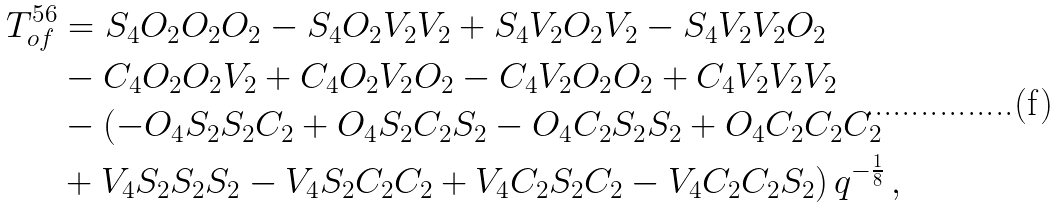Convert formula to latex. <formula><loc_0><loc_0><loc_500><loc_500>T ^ { 5 6 } _ { o f } & = S _ { 4 } O _ { 2 } O _ { 2 } O _ { 2 } - S _ { 4 } O _ { 2 } V _ { 2 } V _ { 2 } + S _ { 4 } V _ { 2 } O _ { 2 } V _ { 2 } - S _ { 4 } V _ { 2 } V _ { 2 } O _ { 2 } \\ & - C _ { 4 } O _ { 2 } O _ { 2 } V _ { 2 } + C _ { 4 } O _ { 2 } V _ { 2 } O _ { 2 } - C _ { 4 } V _ { 2 } O _ { 2 } O _ { 2 } + C _ { 4 } V _ { 2 } V _ { 2 } V _ { 2 } \\ & - ( - O _ { 4 } S _ { 2 } S _ { 2 } C _ { 2 } + O _ { 4 } S _ { 2 } C _ { 2 } S _ { 2 } - O _ { 4 } C _ { 2 } S _ { 2 } S _ { 2 } + O _ { 4 } C _ { 2 } C _ { 2 } C _ { 2 } \\ & + V _ { 4 } S _ { 2 } S _ { 2 } S _ { 2 } - V _ { 4 } S _ { 2 } C _ { 2 } C _ { 2 } + V _ { 4 } C _ { 2 } S _ { 2 } C _ { 2 } - V _ { 4 } C _ { 2 } C _ { 2 } S _ { 2 } ) \, q ^ { - \frac { 1 } { 8 } } \, , \\</formula> 